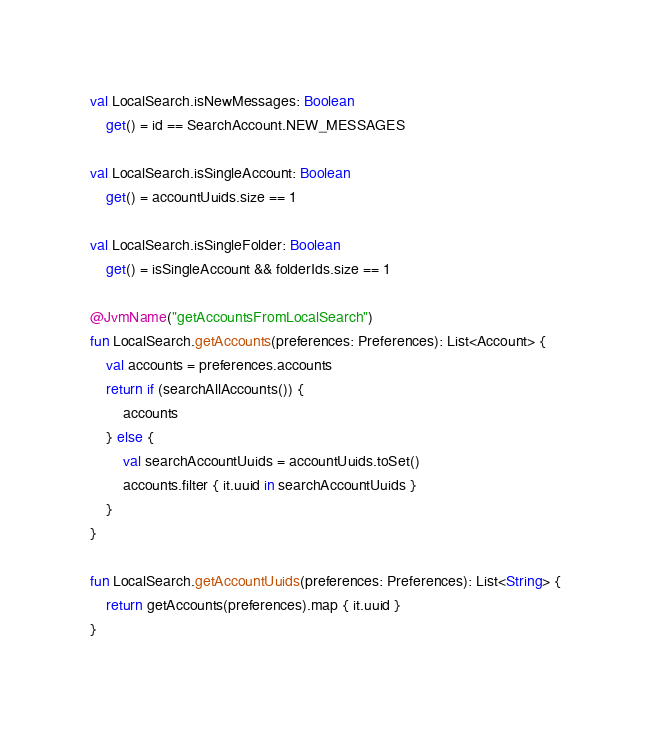Convert code to text. <code><loc_0><loc_0><loc_500><loc_500><_Kotlin_>val LocalSearch.isNewMessages: Boolean
    get() = id == SearchAccount.NEW_MESSAGES

val LocalSearch.isSingleAccount: Boolean
    get() = accountUuids.size == 1

val LocalSearch.isSingleFolder: Boolean
    get() = isSingleAccount && folderIds.size == 1

@JvmName("getAccountsFromLocalSearch")
fun LocalSearch.getAccounts(preferences: Preferences): List<Account> {
    val accounts = preferences.accounts
    return if (searchAllAccounts()) {
        accounts
    } else {
        val searchAccountUuids = accountUuids.toSet()
        accounts.filter { it.uuid in searchAccountUuids }
    }
}

fun LocalSearch.getAccountUuids(preferences: Preferences): List<String> {
    return getAccounts(preferences).map { it.uuid }
}
</code> 